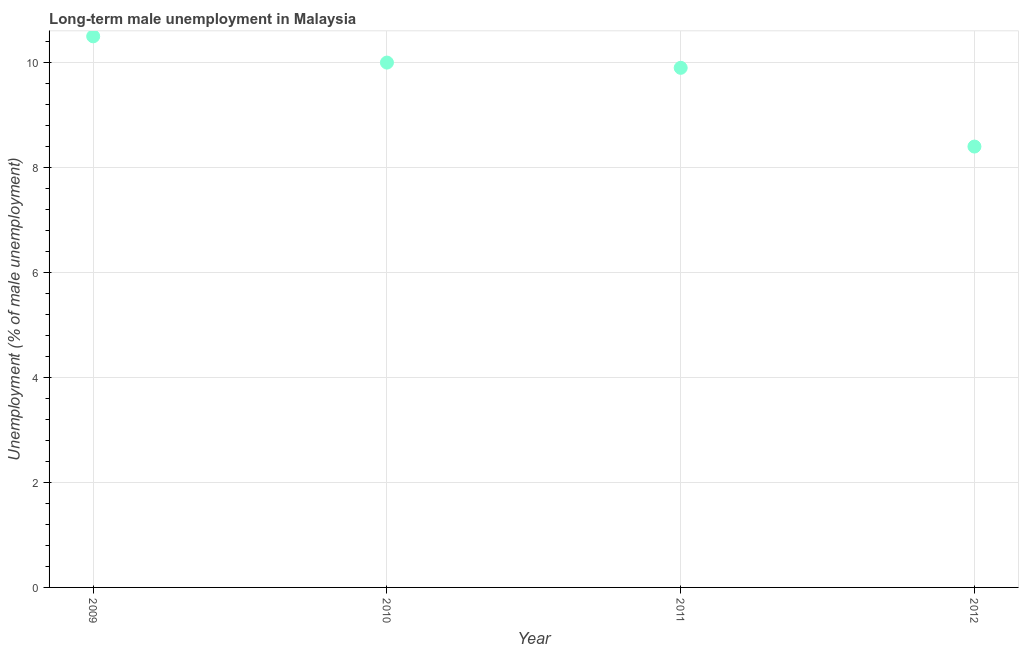What is the long-term male unemployment in 2011?
Offer a very short reply. 9.9. Across all years, what is the minimum long-term male unemployment?
Provide a succinct answer. 8.4. What is the sum of the long-term male unemployment?
Your answer should be very brief. 38.8. What is the average long-term male unemployment per year?
Your answer should be very brief. 9.7. What is the median long-term male unemployment?
Give a very brief answer. 9.95. What is the ratio of the long-term male unemployment in 2011 to that in 2012?
Your answer should be very brief. 1.18. Is the difference between the long-term male unemployment in 2011 and 2012 greater than the difference between any two years?
Provide a short and direct response. No. Is the sum of the long-term male unemployment in 2011 and 2012 greater than the maximum long-term male unemployment across all years?
Your answer should be compact. Yes. What is the difference between the highest and the lowest long-term male unemployment?
Keep it short and to the point. 2.1. What is the difference between two consecutive major ticks on the Y-axis?
Make the answer very short. 2. Are the values on the major ticks of Y-axis written in scientific E-notation?
Offer a terse response. No. What is the title of the graph?
Your response must be concise. Long-term male unemployment in Malaysia. What is the label or title of the Y-axis?
Provide a succinct answer. Unemployment (% of male unemployment). What is the Unemployment (% of male unemployment) in 2009?
Make the answer very short. 10.5. What is the Unemployment (% of male unemployment) in 2011?
Provide a short and direct response. 9.9. What is the Unemployment (% of male unemployment) in 2012?
Make the answer very short. 8.4. What is the difference between the Unemployment (% of male unemployment) in 2009 and 2010?
Make the answer very short. 0.5. What is the difference between the Unemployment (% of male unemployment) in 2010 and 2011?
Offer a terse response. 0.1. What is the difference between the Unemployment (% of male unemployment) in 2011 and 2012?
Your answer should be very brief. 1.5. What is the ratio of the Unemployment (% of male unemployment) in 2009 to that in 2011?
Offer a terse response. 1.06. What is the ratio of the Unemployment (% of male unemployment) in 2010 to that in 2012?
Give a very brief answer. 1.19. What is the ratio of the Unemployment (% of male unemployment) in 2011 to that in 2012?
Provide a succinct answer. 1.18. 